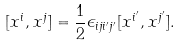Convert formula to latex. <formula><loc_0><loc_0><loc_500><loc_500>[ x ^ { i } , x ^ { j } ] = \frac { 1 } { 2 } \epsilon _ { i j i ^ { \prime } j ^ { \prime } } [ x ^ { i ^ { \prime } } , x ^ { j ^ { \prime } } ] .</formula> 